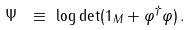Convert formula to latex. <formula><loc_0><loc_0><loc_500><loc_500>\Psi \ & \equiv \ \log \det ( { 1 } _ { M } + \varphi ^ { \dagger } \varphi ) \, .</formula> 